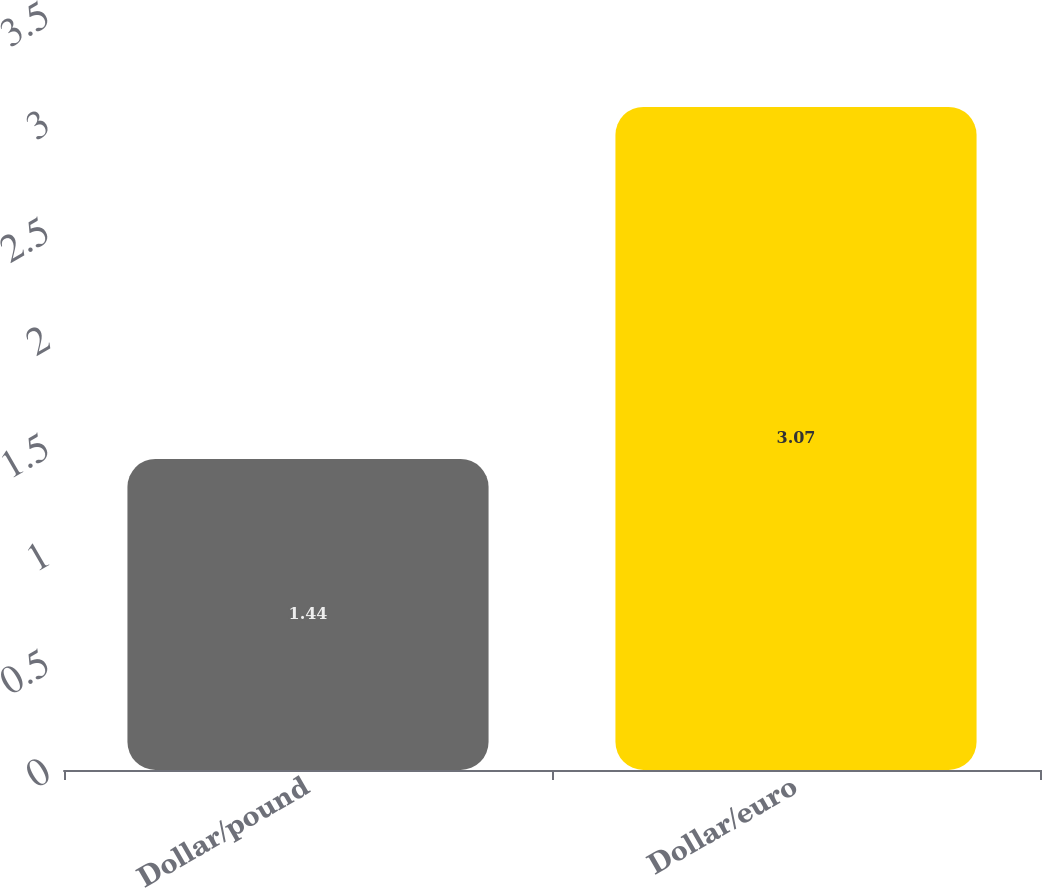<chart> <loc_0><loc_0><loc_500><loc_500><bar_chart><fcel>Dollar/pound<fcel>Dollar/euro<nl><fcel>1.44<fcel>3.07<nl></chart> 